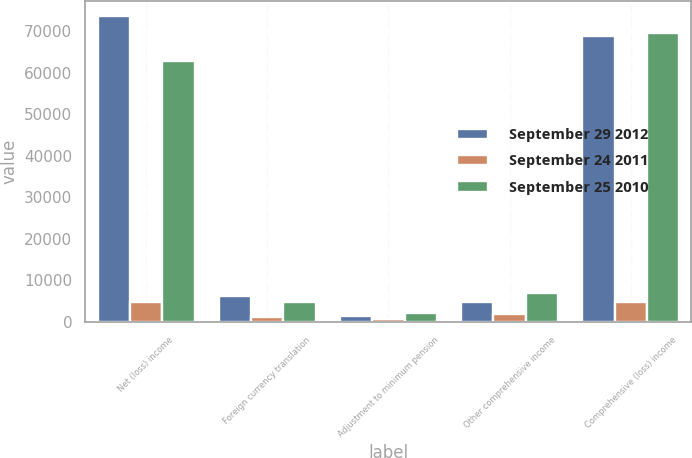<chart> <loc_0><loc_0><loc_500><loc_500><stacked_bar_chart><ecel><fcel>Net (loss) income<fcel>Foreign currency translation<fcel>Adjustment to minimum pension<fcel>Other comprehensive income<fcel>Comprehensive (loss) income<nl><fcel>September 29 2012<fcel>73634<fcel>6217<fcel>1484<fcel>4795<fcel>68839<nl><fcel>September 24 2011<fcel>4795<fcel>1088<fcel>764<fcel>1852<fcel>4795<nl><fcel>September 25 2010<fcel>62813<fcel>4763<fcel>2122<fcel>6885<fcel>69698<nl></chart> 